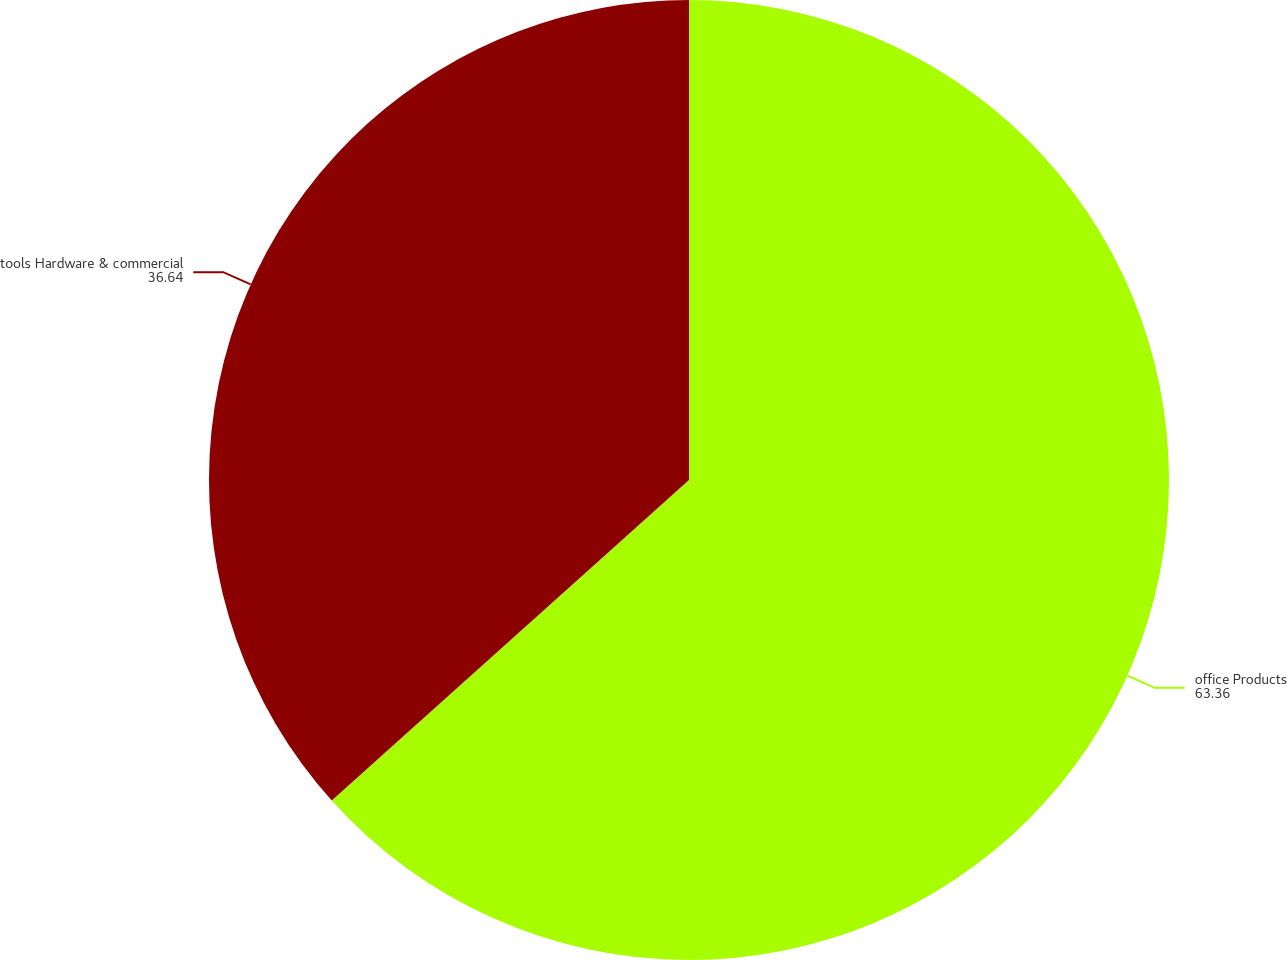Convert chart. <chart><loc_0><loc_0><loc_500><loc_500><pie_chart><fcel>office Products<fcel>tools Hardware & commercial<nl><fcel>63.36%<fcel>36.64%<nl></chart> 